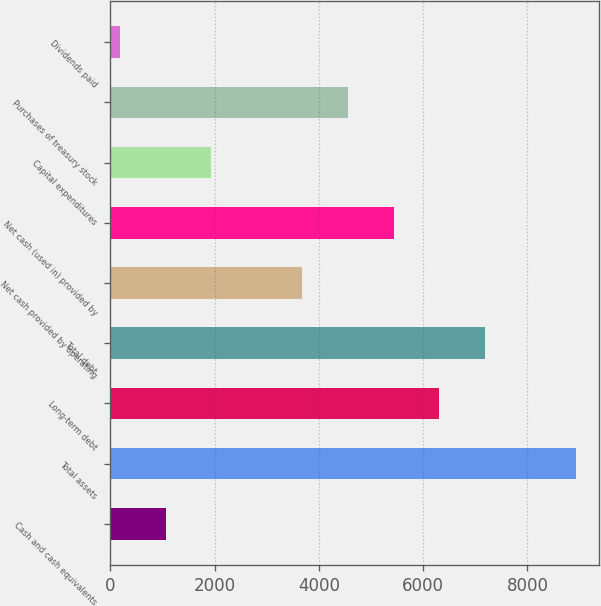Convert chart to OTSL. <chart><loc_0><loc_0><loc_500><loc_500><bar_chart><fcel>Cash and cash equivalents<fcel>Total assets<fcel>Long-term debt<fcel>Total debt<fcel>Net cash provided by operating<fcel>Net cash (used in) provided by<fcel>Capital expenditures<fcel>Purchases of treasury stock<fcel>Dividends paid<nl><fcel>1059.5<fcel>8930<fcel>6306.5<fcel>7181<fcel>3683<fcel>5432<fcel>1934<fcel>4557.5<fcel>185<nl></chart> 